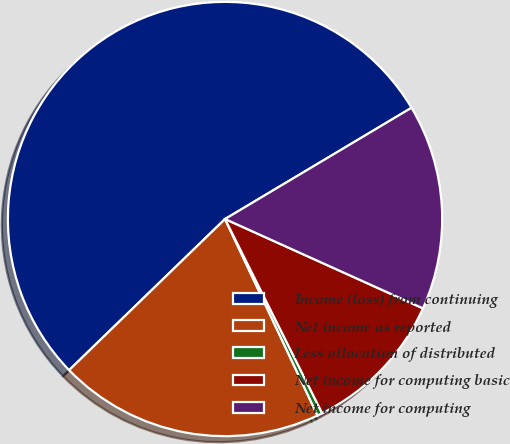Convert chart. <chart><loc_0><loc_0><loc_500><loc_500><pie_chart><fcel>Income (loss) from continuing<fcel>Net income as reported<fcel>Less allocation of distributed<fcel>Net income for computing basic<fcel>Net income for computing<nl><fcel>53.69%<fcel>19.75%<fcel>0.38%<fcel>10.87%<fcel>15.31%<nl></chart> 